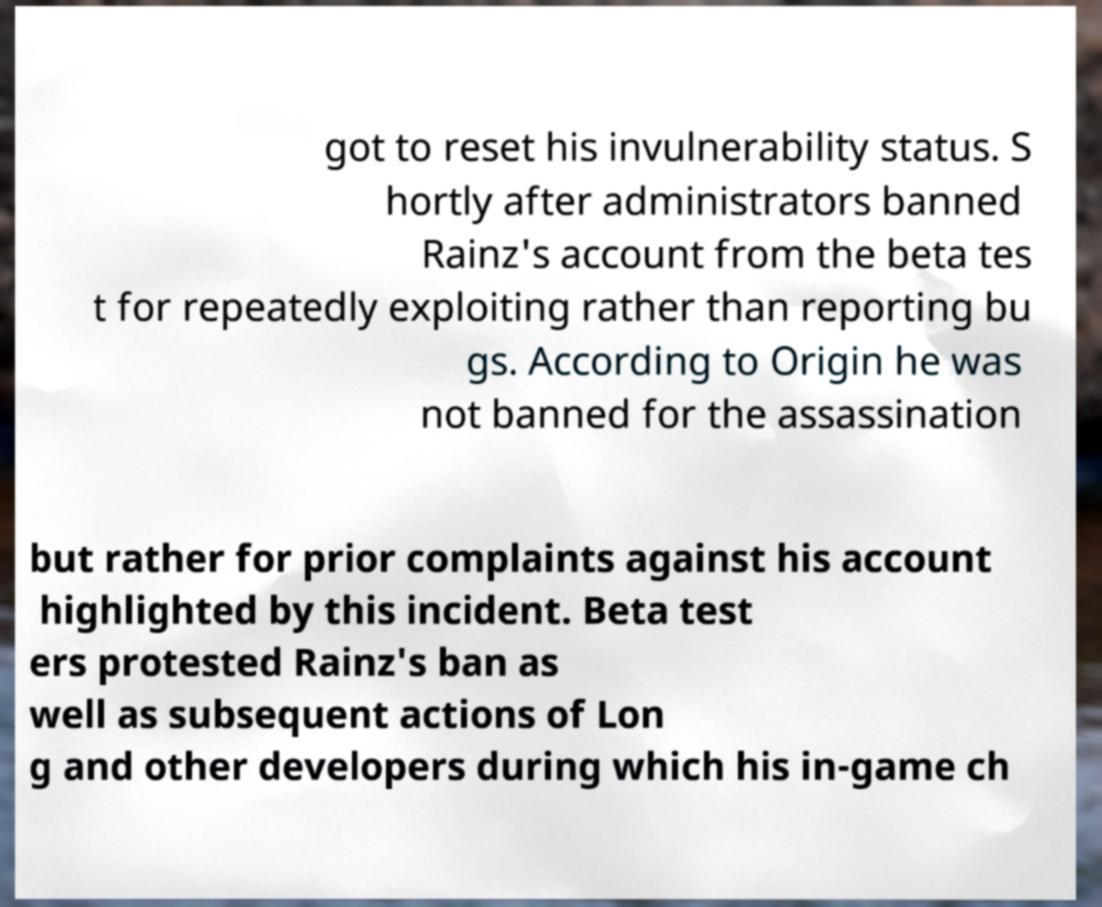There's text embedded in this image that I need extracted. Can you transcribe it verbatim? got to reset his invulnerability status. S hortly after administrators banned Rainz's account from the beta tes t for repeatedly exploiting rather than reporting bu gs. According to Origin he was not banned for the assassination but rather for prior complaints against his account highlighted by this incident. Beta test ers protested Rainz's ban as well as subsequent actions of Lon g and other developers during which his in-game ch 